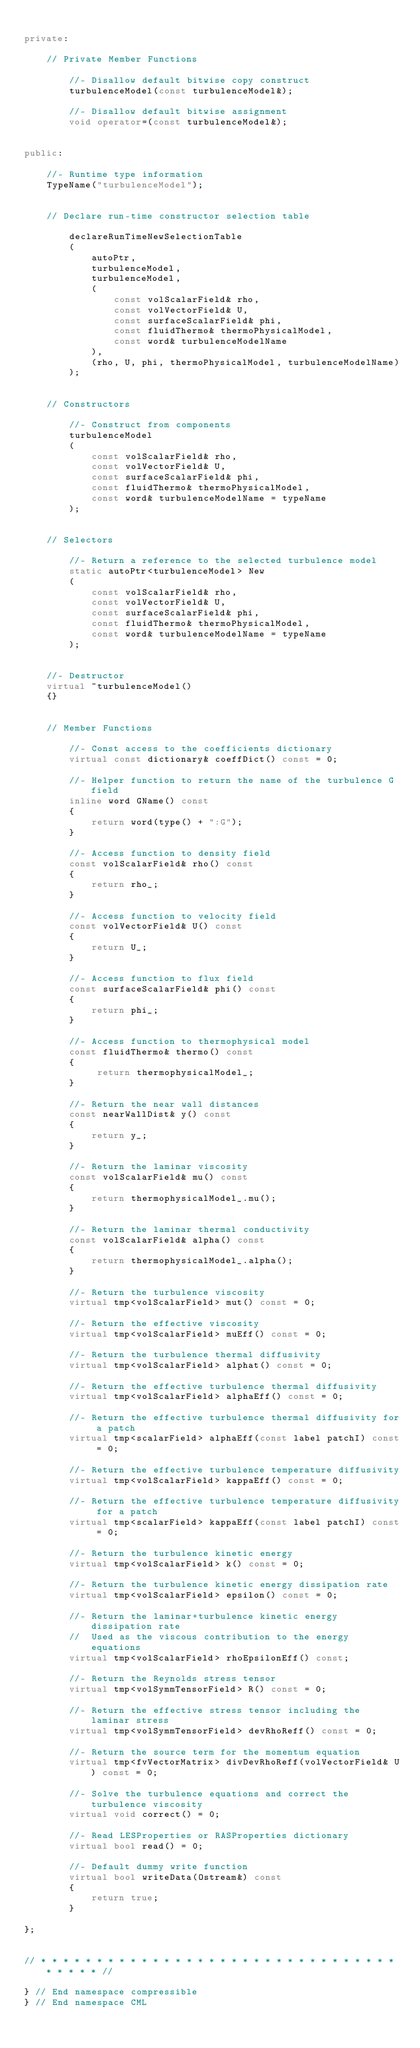Convert code to text. <code><loc_0><loc_0><loc_500><loc_500><_C++_>
private:

    // Private Member Functions

        //- Disallow default bitwise copy construct
        turbulenceModel(const turbulenceModel&);

        //- Disallow default bitwise assignment
        void operator=(const turbulenceModel&);


public:

    //- Runtime type information
    TypeName("turbulenceModel");


    // Declare run-time constructor selection table

        declareRunTimeNewSelectionTable
        (
            autoPtr,
            turbulenceModel,
            turbulenceModel,
            (
                const volScalarField& rho,
                const volVectorField& U,
                const surfaceScalarField& phi,
                const fluidThermo& thermoPhysicalModel,
                const word& turbulenceModelName
            ),
            (rho, U, phi, thermoPhysicalModel, turbulenceModelName)
        );


    // Constructors

        //- Construct from components
        turbulenceModel
        (
            const volScalarField& rho,
            const volVectorField& U,
            const surfaceScalarField& phi,
            const fluidThermo& thermoPhysicalModel,
            const word& turbulenceModelName = typeName
        );


    // Selectors

        //- Return a reference to the selected turbulence model
        static autoPtr<turbulenceModel> New
        (
            const volScalarField& rho,
            const volVectorField& U,
            const surfaceScalarField& phi,
            const fluidThermo& thermoPhysicalModel,
            const word& turbulenceModelName = typeName
        );


    //- Destructor
    virtual ~turbulenceModel()
    {}


    // Member Functions

        //- Const access to the coefficients dictionary
        virtual const dictionary& coeffDict() const = 0;

        //- Helper function to return the name of the turbulence G field
        inline word GName() const
        {
            return word(type() + ":G");
        }

        //- Access function to density field
        const volScalarField& rho() const
        {
            return rho_;
        }

        //- Access function to velocity field
        const volVectorField& U() const
        {
            return U_;
        }

        //- Access function to flux field
        const surfaceScalarField& phi() const
        {
            return phi_;
        }

        //- Access function to thermophysical model
        const fluidThermo& thermo() const
        {
             return thermophysicalModel_;
        }

        //- Return the near wall distances
        const nearWallDist& y() const
        {
            return y_;
        }

        //- Return the laminar viscosity
        const volScalarField& mu() const
        {
            return thermophysicalModel_.mu();
        }

        //- Return the laminar thermal conductivity
        const volScalarField& alpha() const
        {
            return thermophysicalModel_.alpha();
        }

        //- Return the turbulence viscosity
        virtual tmp<volScalarField> mut() const = 0;

        //- Return the effective viscosity
        virtual tmp<volScalarField> muEff() const = 0;

        //- Return the turbulence thermal diffusivity
        virtual tmp<volScalarField> alphat() const = 0;

        //- Return the effective turbulence thermal diffusivity
        virtual tmp<volScalarField> alphaEff() const = 0;

        //- Return the effective turbulence thermal diffusivity for a patch
        virtual tmp<scalarField> alphaEff(const label patchI) const = 0;

        //- Return the effective turbulence temperature diffusivity
        virtual tmp<volScalarField> kappaEff() const = 0;

        //- Return the effective turbulence temperature diffusivity for a patch
        virtual tmp<scalarField> kappaEff(const label patchI) const = 0;

        //- Return the turbulence kinetic energy
        virtual tmp<volScalarField> k() const = 0;

        //- Return the turbulence kinetic energy dissipation rate
        virtual tmp<volScalarField> epsilon() const = 0;

        //- Return the laminar+turbulence kinetic energy dissipation rate
        //  Used as the viscous contribution to the energy equations
        virtual tmp<volScalarField> rhoEpsilonEff() const;

        //- Return the Reynolds stress tensor
        virtual tmp<volSymmTensorField> R() const = 0;

        //- Return the effective stress tensor including the laminar stress
        virtual tmp<volSymmTensorField> devRhoReff() const = 0;

        //- Return the source term for the momentum equation
        virtual tmp<fvVectorMatrix> divDevRhoReff(volVectorField& U) const = 0;

        //- Solve the turbulence equations and correct the turbulence viscosity
        virtual void correct() = 0;

        //- Read LESProperties or RASProperties dictionary
        virtual bool read() = 0;

        //- Default dummy write function
        virtual bool writeData(Ostream&) const
        {
            return true;
        }

};


// * * * * * * * * * * * * * * * * * * * * * * * * * * * * * * * * * * * * * //

} // End namespace compressible
} // End namespace CML
</code> 